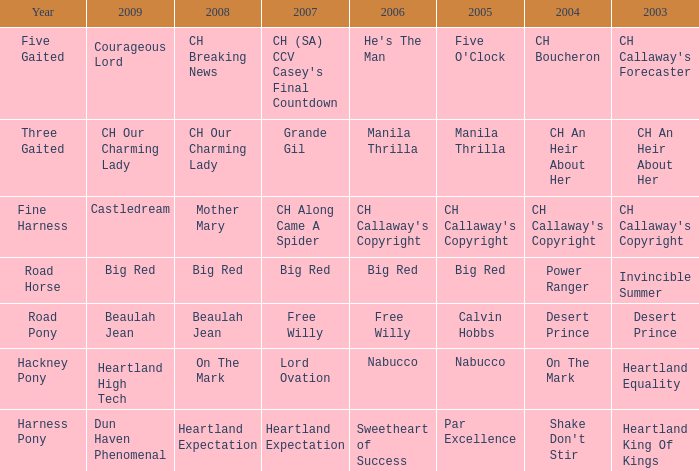What year is the 2004 shake don't stir? Harness Pony. 